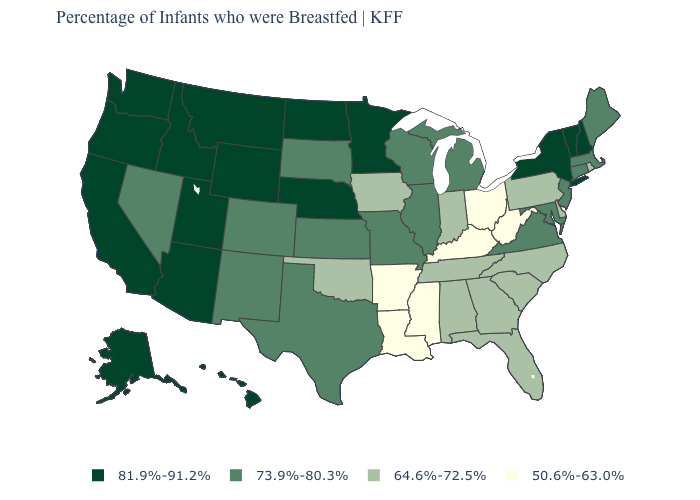What is the value of Tennessee?
Be succinct. 64.6%-72.5%. Does the map have missing data?
Be succinct. No. What is the value of Pennsylvania?
Concise answer only. 64.6%-72.5%. Does Massachusetts have a higher value than Maryland?
Answer briefly. No. Name the states that have a value in the range 50.6%-63.0%?
Be succinct. Arkansas, Kentucky, Louisiana, Mississippi, Ohio, West Virginia. What is the highest value in the USA?
Keep it brief. 81.9%-91.2%. Which states hav the highest value in the MidWest?
Write a very short answer. Minnesota, Nebraska, North Dakota. Does New Mexico have a lower value than Alabama?
Answer briefly. No. Does Vermont have the lowest value in the USA?
Write a very short answer. No. Name the states that have a value in the range 64.6%-72.5%?
Keep it brief. Alabama, Delaware, Florida, Georgia, Indiana, Iowa, North Carolina, Oklahoma, Pennsylvania, Rhode Island, South Carolina, Tennessee. What is the value of Missouri?
Quick response, please. 73.9%-80.3%. What is the highest value in states that border Arkansas?
Quick response, please. 73.9%-80.3%. Does the map have missing data?
Quick response, please. No. Name the states that have a value in the range 73.9%-80.3%?
Quick response, please. Colorado, Connecticut, Illinois, Kansas, Maine, Maryland, Massachusetts, Michigan, Missouri, Nevada, New Jersey, New Mexico, South Dakota, Texas, Virginia, Wisconsin. Does Missouri have the lowest value in the MidWest?
Short answer required. No. 